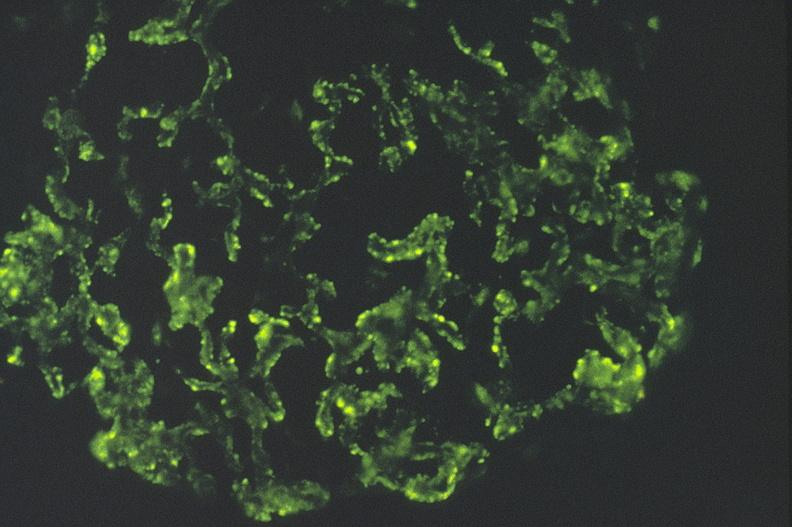where is this?
Answer the question using a single word or phrase. Urinary 